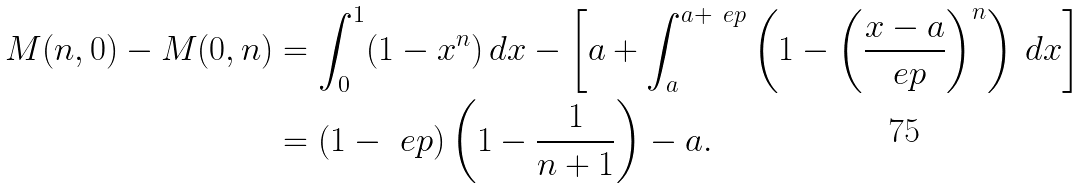<formula> <loc_0><loc_0><loc_500><loc_500>M ( n , 0 ) - M ( 0 , n ) & = \int _ { 0 } ^ { 1 } ( 1 - x ^ { n } ) \, d x - \left [ a + \int _ { a } ^ { a + \ e p } \left ( 1 - \left ( \frac { x - a } { \ e p } \right ) ^ { n } \right ) \, d x \right ] \\ & = ( 1 - \ e p ) \left ( 1 - \frac { 1 } { n + 1 } \right ) - a .</formula> 